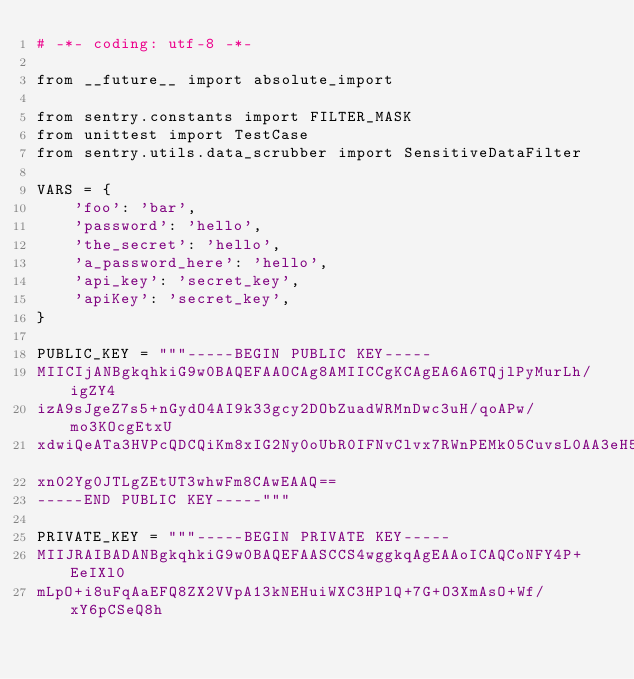<code> <loc_0><loc_0><loc_500><loc_500><_Python_># -*- coding: utf-8 -*-

from __future__ import absolute_import

from sentry.constants import FILTER_MASK
from unittest import TestCase
from sentry.utils.data_scrubber import SensitiveDataFilter

VARS = {
    'foo': 'bar',
    'password': 'hello',
    'the_secret': 'hello',
    'a_password_here': 'hello',
    'api_key': 'secret_key',
    'apiKey': 'secret_key',
}

PUBLIC_KEY = """-----BEGIN PUBLIC KEY-----
MIICIjANBgkqhkiG9w0BAQEFAAOCAg8AMIICCgKCAgEA6A6TQjlPyMurLh/igZY4
izA9sJgeZ7s5+nGydO4AI9k33gcy2DObZuadWRMnDwc3uH/qoAPw/mo3KOcgEtxU
xdwiQeATa3HVPcQDCQiKm8xIG2Ny0oUbR0IFNvClvx7RWnPEMk05CuvsL0AA3eH5
xn02Yg0JTLgZEtUT3whwFm8CAwEAAQ==
-----END PUBLIC KEY-----"""

PRIVATE_KEY = """-----BEGIN PRIVATE KEY-----
MIIJRAIBADANBgkqhkiG9w0BAQEFAASCCS4wggkqAgEAAoICAQCoNFY4P+EeIXl0
mLpO+i8uFqAaEFQ8ZX2VVpA13kNEHuiWXC3HPlQ+7G+O3XmAsO+Wf/xY6pCSeQ8h</code> 